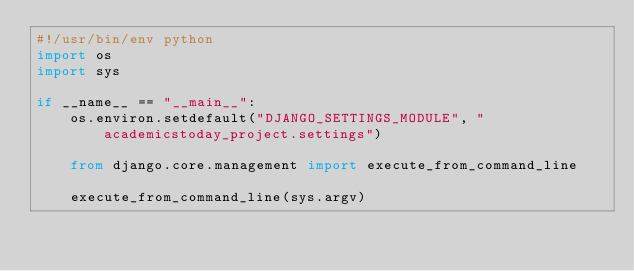Convert code to text. <code><loc_0><loc_0><loc_500><loc_500><_Python_>#!/usr/bin/env python
import os
import sys

if __name__ == "__main__":
    os.environ.setdefault("DJANGO_SETTINGS_MODULE", "academicstoday_project.settings")

    from django.core.management import execute_from_command_line

    execute_from_command_line(sys.argv)
</code> 